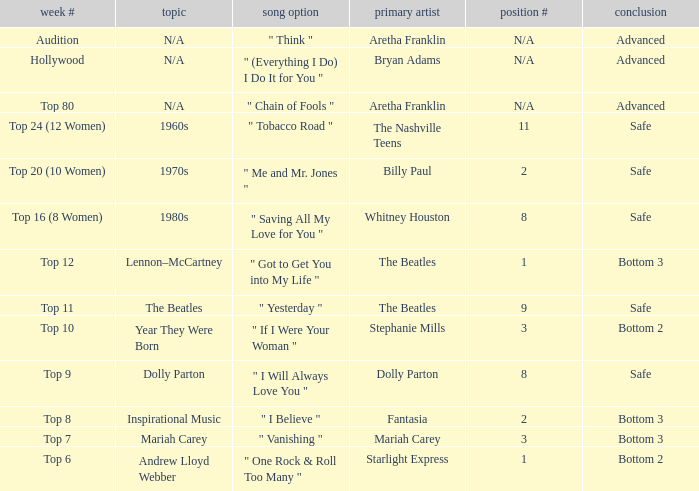Name the song choice when week number is hollywood " (Everything I Do) I Do It for You ". 